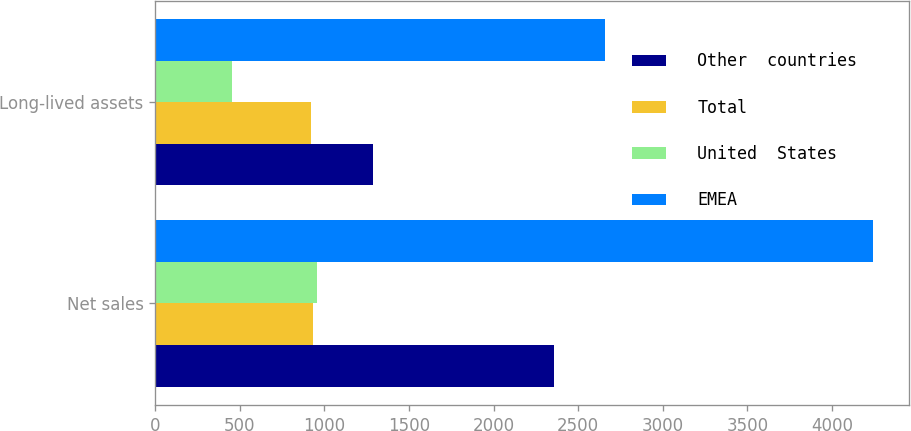Convert chart. <chart><loc_0><loc_0><loc_500><loc_500><stacked_bar_chart><ecel><fcel>Net sales<fcel>Long-lived assets<nl><fcel>Other  countries<fcel>2357.5<fcel>1284<nl><fcel>Total<fcel>930.8<fcel>920<nl><fcel>United  States<fcel>954.9<fcel>451.7<nl><fcel>EMEA<fcel>4243.2<fcel>2655.7<nl></chart> 